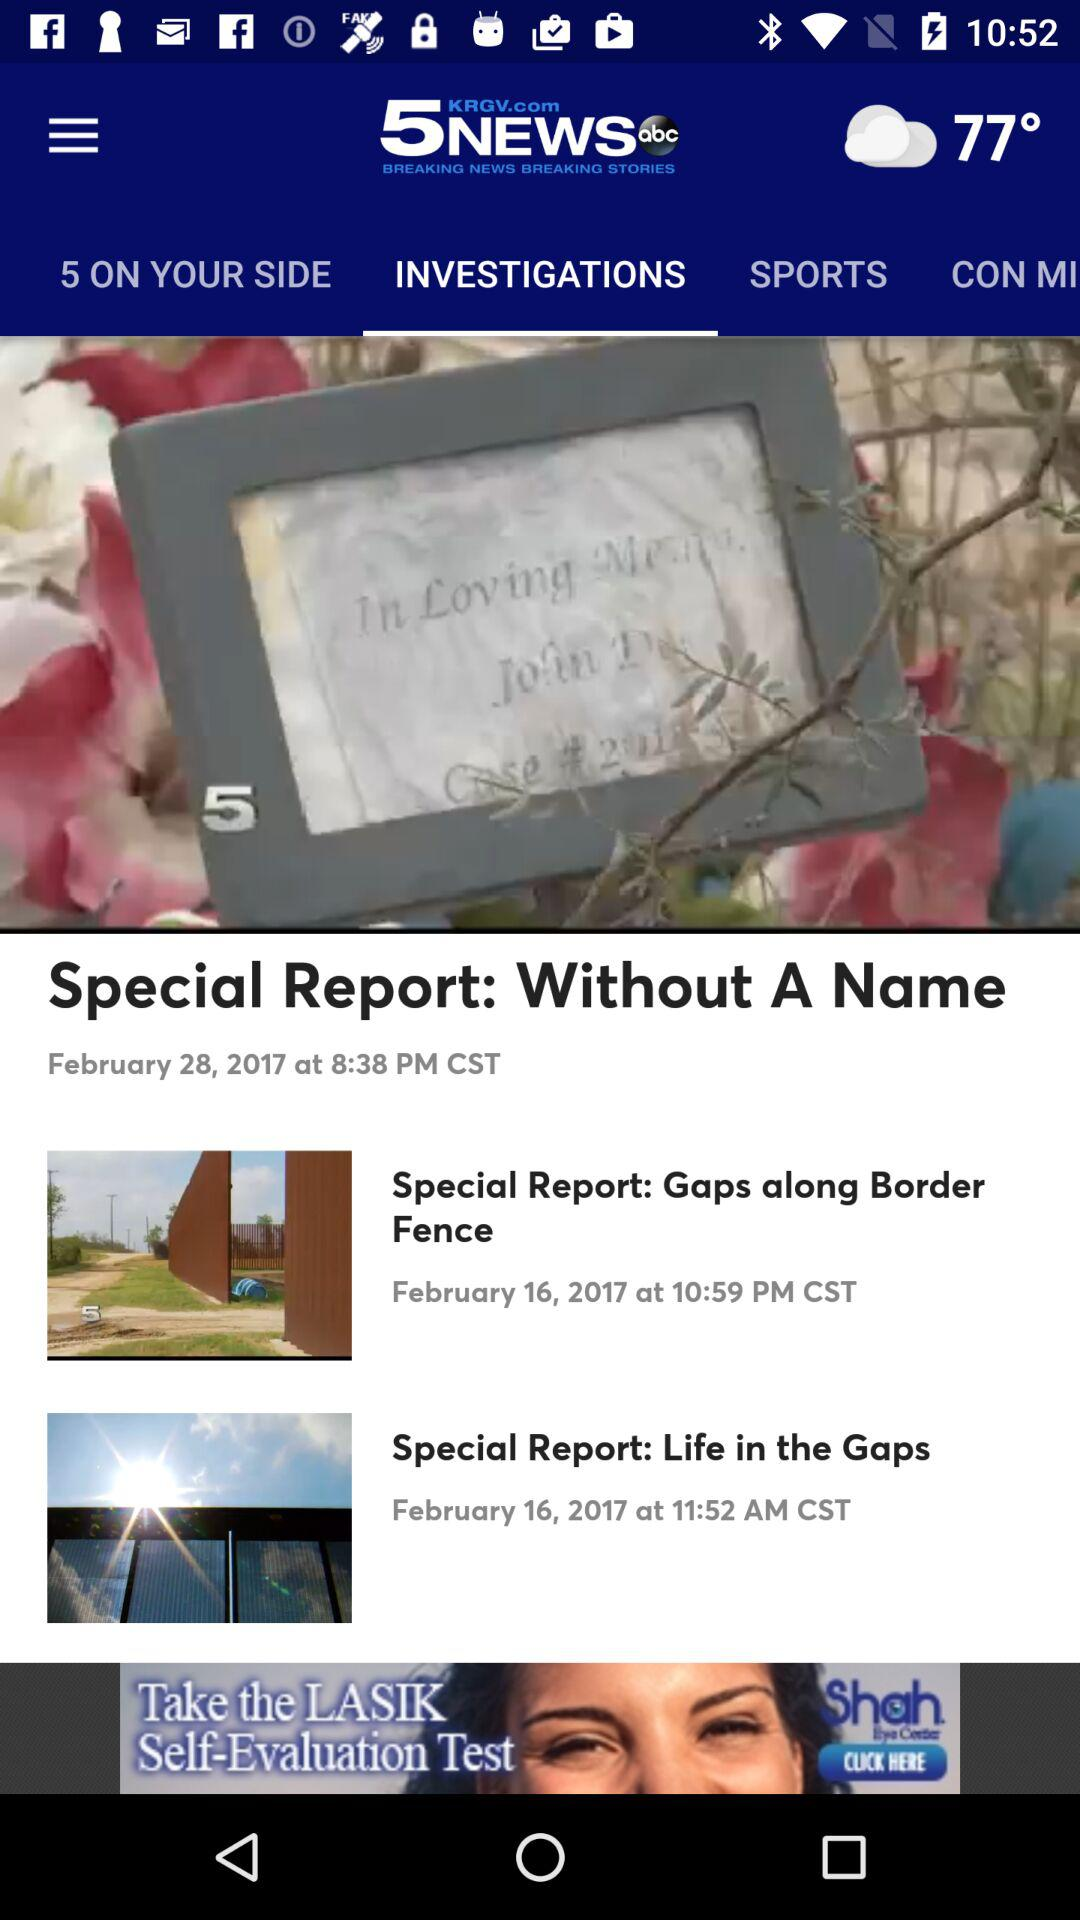How many special reports are there on the screen?
Answer the question using a single word or phrase. 3 